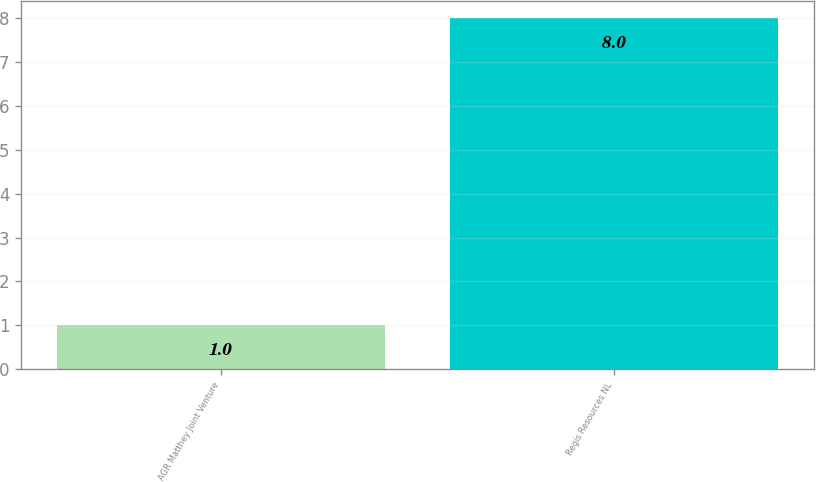Convert chart to OTSL. <chart><loc_0><loc_0><loc_500><loc_500><bar_chart><fcel>AGR Matthey Joint Venture<fcel>Regis Resources NL<nl><fcel>1<fcel>8<nl></chart> 